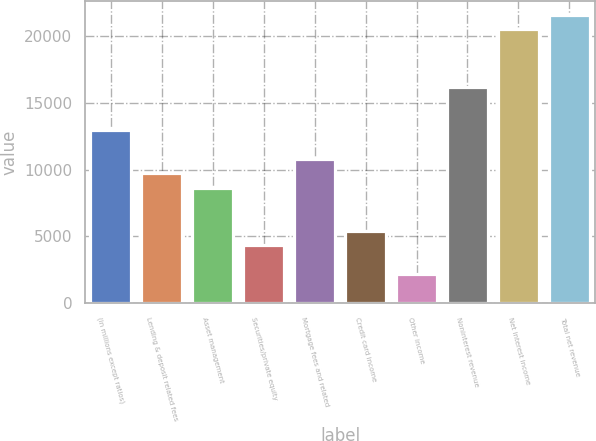<chart> <loc_0><loc_0><loc_500><loc_500><bar_chart><fcel>(in millions except ratios)<fcel>Lending & deposit related fees<fcel>Asset management<fcel>Securities/private equity<fcel>Mortgage fees and related<fcel>Credit card income<fcel>Other income<fcel>Noninterest revenue<fcel>Net interest income<fcel>Total net revenue<nl><fcel>12948.9<fcel>9712<fcel>8633.02<fcel>4317.1<fcel>10791<fcel>5396.08<fcel>2159.14<fcel>16185.9<fcel>20501.8<fcel>21580.8<nl></chart> 